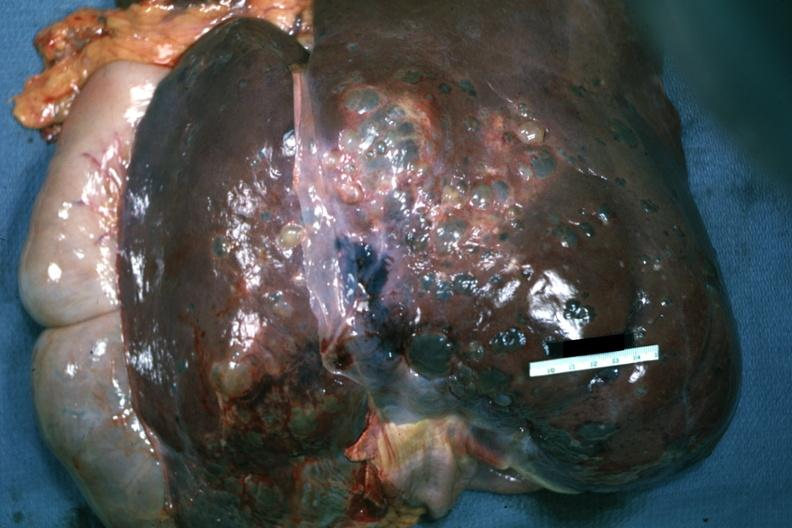what does this image show?
Answer the question using a single word or phrase. Anterior view of removed and non-sectioned liver as surgeon would see thcase of polycystic disease 